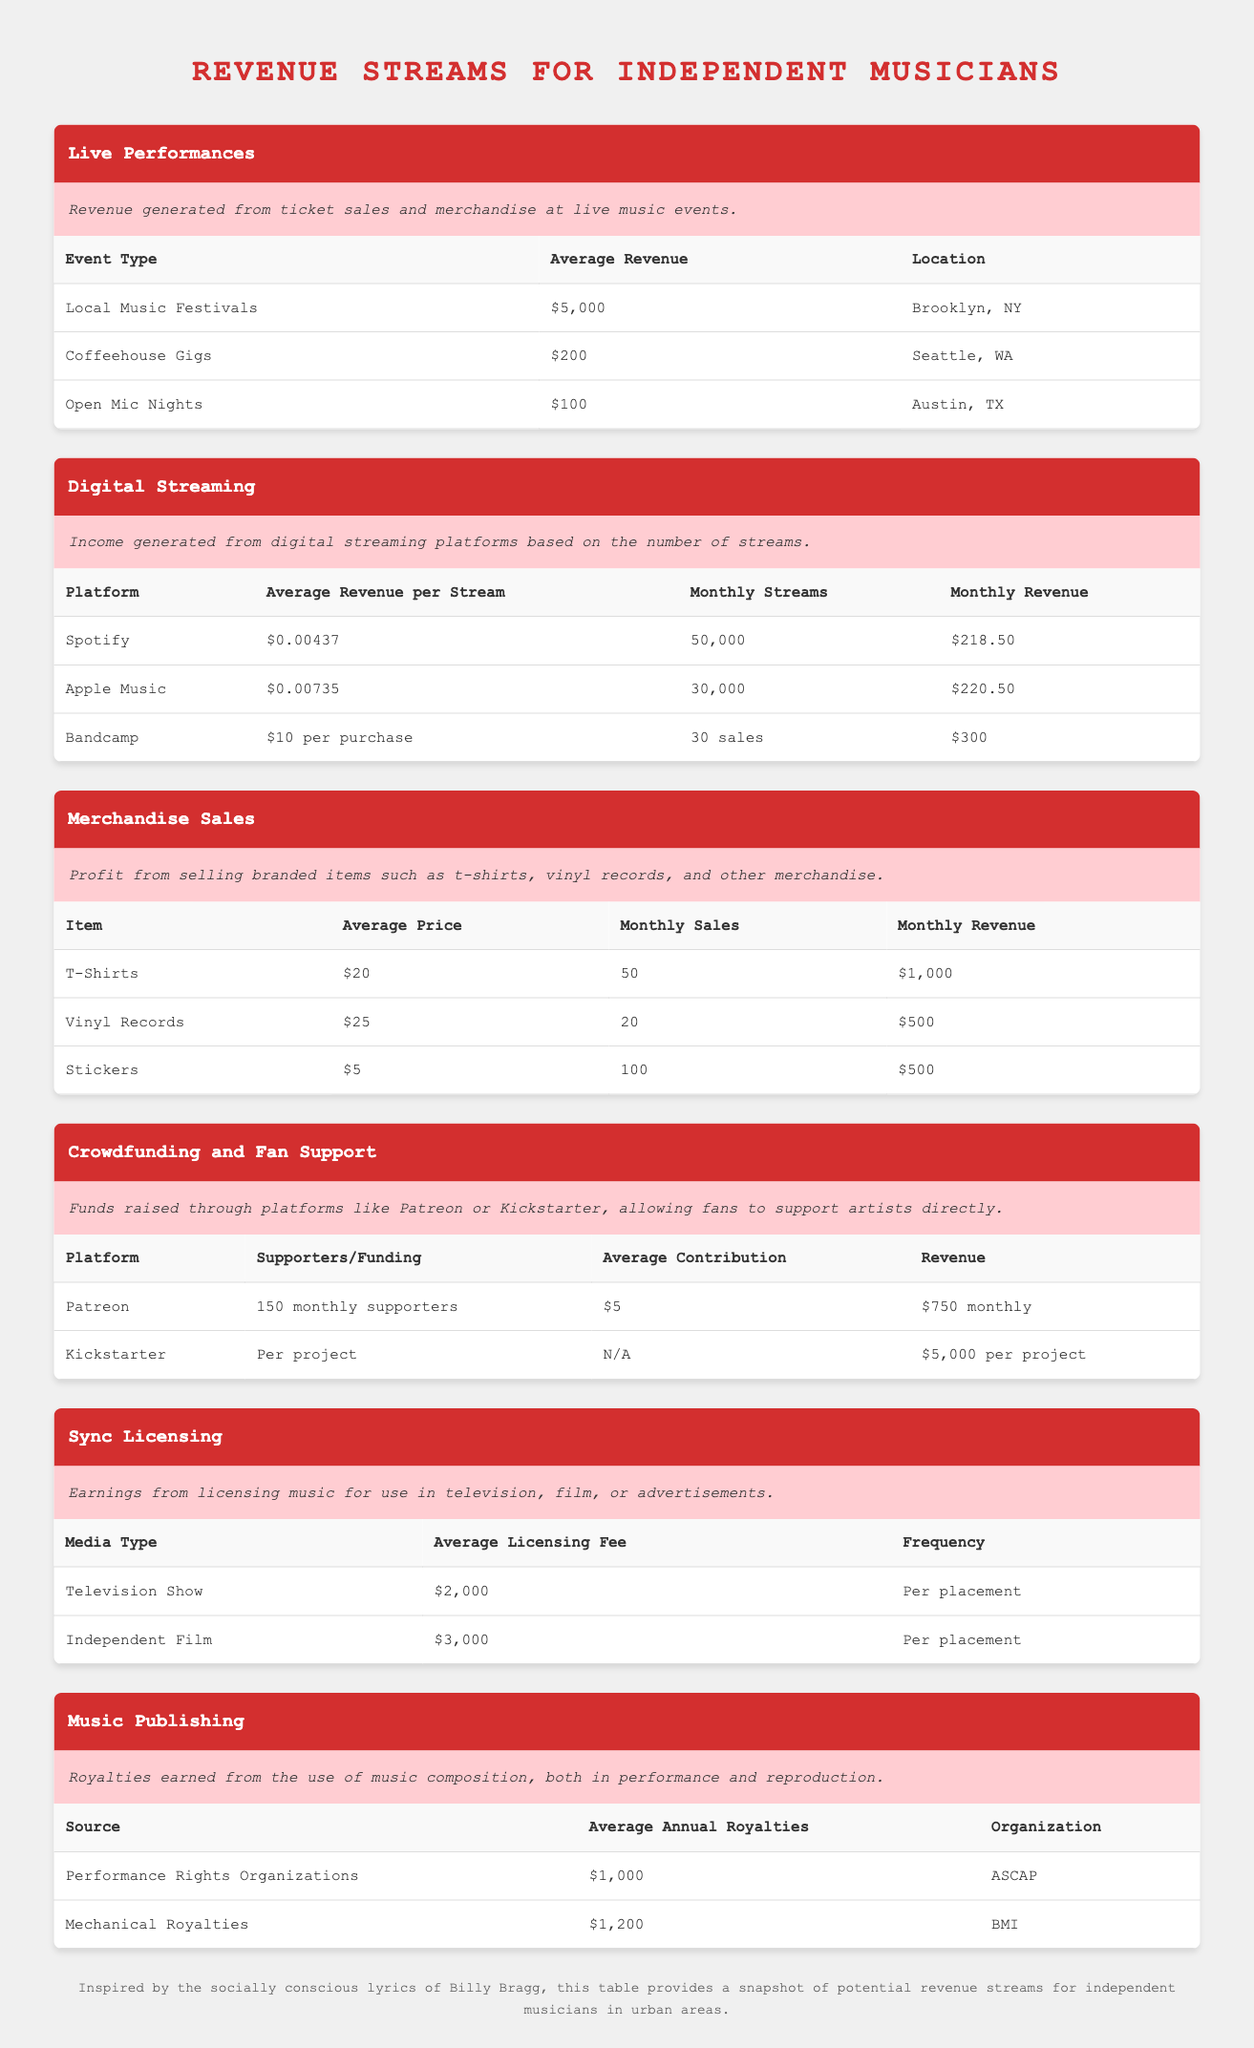What is the average revenue from live performances at local music festivals? From the table under Live Performances, the average revenue for local music festivals is listed as $5,000. Therefore, the average revenue directly shown in the table is $5,000.
Answer: $5,000 Which digital streaming platform has the highest average revenue per stream? The table indicates that Apple's Music has an average revenue per stream of $0.00735, while Spotify has $0.00437. Since Bandcamp lists revenue per purchase instead, the highest average revenue per stream can be determined by comparing the two stream-based platforms, concluding that Apple Music is higher.
Answer: Apple Music What is the total monthly revenue from merchandise sales? The total monthly revenue can be calculated by summing the individual monthly revenues: T-Shirts ($1,000) + Vinyl Records ($500) + Stickers ($500) = $2,000 total monthly revenue from merchandise sales.
Answer: $2,000 Is it true that the average licensing fee for an independent film is more than that for a television show? The average licensing fee for an independent film is $3,000, while for a television show it is $2,000. Since $3,000 is greater than $2,000, the fact is true.
Answer: Yes If an artist has 150 supporters on Patreon each contributing an average of $5, what would be the expected monthly revenue? The expected monthly revenue can be calculated by multiplying the number of supporters (150) by the average contribution ($5). Thus, 150 * $5 = $750 expected monthly revenue from Patreon supporters.
Answer: $750 What is the average annual royalty earned from performance rights organizations? According to the table, average annual royalties from performance rights organizations like ASCAP is reported as $1,000.
Answer: $1,000 What is the average monthly revenue from streaming platforms based on the example provided for Spotify? The average monthly revenue from Spotify listed in the table is $218.50.
Answer: $218.50 What is the combined total average revenue from merchandise sales for T-Shirts and Vinyl Records? The total can be figured by adding the revenue from T-Shirts ($1,000) and Vinyl Records ($500), resulting in a combined average revenue of $1,500 for these merchandise items.
Answer: $1,500 How many different revenue streams are listed in the table? The table provides six revenue streams: Live Performances, Digital Streaming, Merchandise Sales, Crowdfunding and Fan Support, Sync Licensing, and Music Publishing, thus the total number of different revenue streams is six.
Answer: 6 